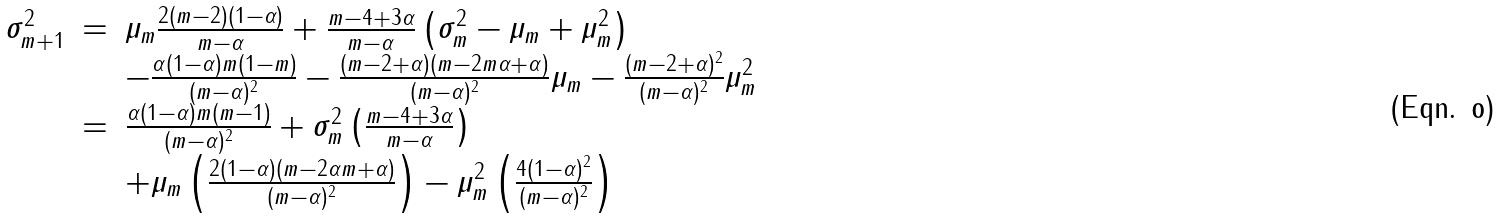Convert formula to latex. <formula><loc_0><loc_0><loc_500><loc_500>\begin{array} { r c l } \sigma _ { m + 1 } ^ { 2 } & = & \mu _ { m } \frac { 2 ( m - 2 ) ( 1 - \alpha ) } { m - \alpha } + \frac { m - 4 + 3 \alpha } { m - \alpha } \left ( \sigma _ { m } ^ { 2 } - \mu _ { m } + \mu _ { m } ^ { 2 } \right ) \\ & & - \frac { \alpha ( 1 - \alpha ) m ( 1 - m ) } { ( m - \alpha ) ^ { 2 } } - \frac { ( m - 2 + \alpha ) ( m - 2 m \alpha + \alpha ) } { ( m - \alpha ) ^ { 2 } } \mu _ { m } - \frac { ( m - 2 + \alpha ) ^ { 2 } } { ( m - \alpha ) ^ { 2 } } \mu _ { m } ^ { 2 } \\ & = & \frac { \alpha ( 1 - \alpha ) m ( m - 1 ) } { ( m - \alpha ) ^ { 2 } } + \sigma _ { m } ^ { 2 } \left ( \frac { m - 4 + 3 \alpha } { m - \alpha } \right ) \\ & & + \mu _ { m } \left ( \frac { 2 ( 1 - \alpha ) ( m - 2 \alpha m + \alpha ) } { ( m - \alpha ) ^ { 2 } } \right ) - \mu _ { m } ^ { 2 } \left ( \frac { 4 ( 1 - \alpha ) ^ { 2 } } { ( m - \alpha ) ^ { 2 } } \right ) \end{array}</formula> 